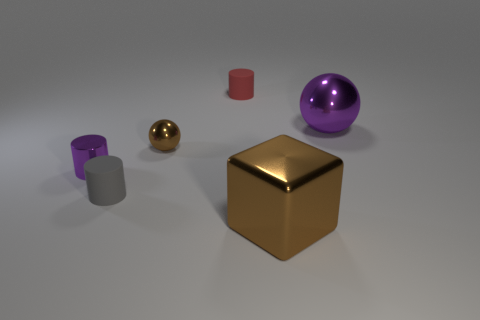Add 1 large green shiny objects. How many objects exist? 7 Subtract all balls. How many objects are left? 4 Add 2 cyan blocks. How many cyan blocks exist? 2 Subtract 1 red cylinders. How many objects are left? 5 Subtract all tiny rubber cylinders. Subtract all tiny shiny spheres. How many objects are left? 3 Add 2 big shiny balls. How many big shiny balls are left? 3 